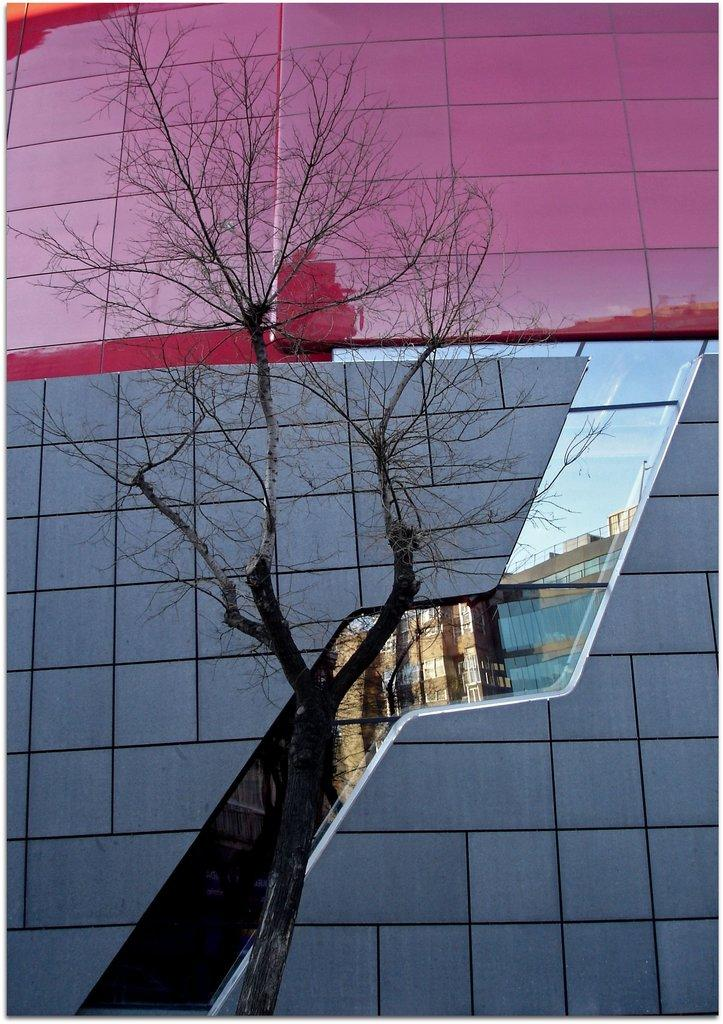What is located in the middle of the image? There is a tree in the middle of the image. What type of structure can be seen at the back side of the image? There is a glass building at the back side of the image. How many sisters are holding the vase in the image? There are no sisters or vase present in the image. What type of button can be seen on the tree in the image? There is no button present on the tree in the image. 